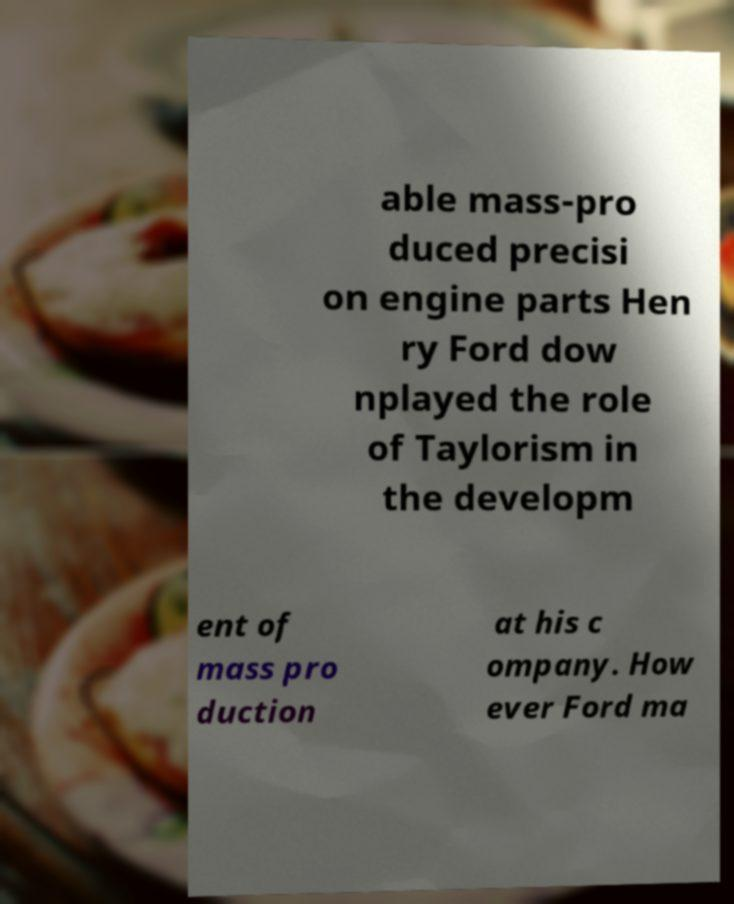Could you extract and type out the text from this image? able mass-pro duced precisi on engine parts Hen ry Ford dow nplayed the role of Taylorism in the developm ent of mass pro duction at his c ompany. How ever Ford ma 